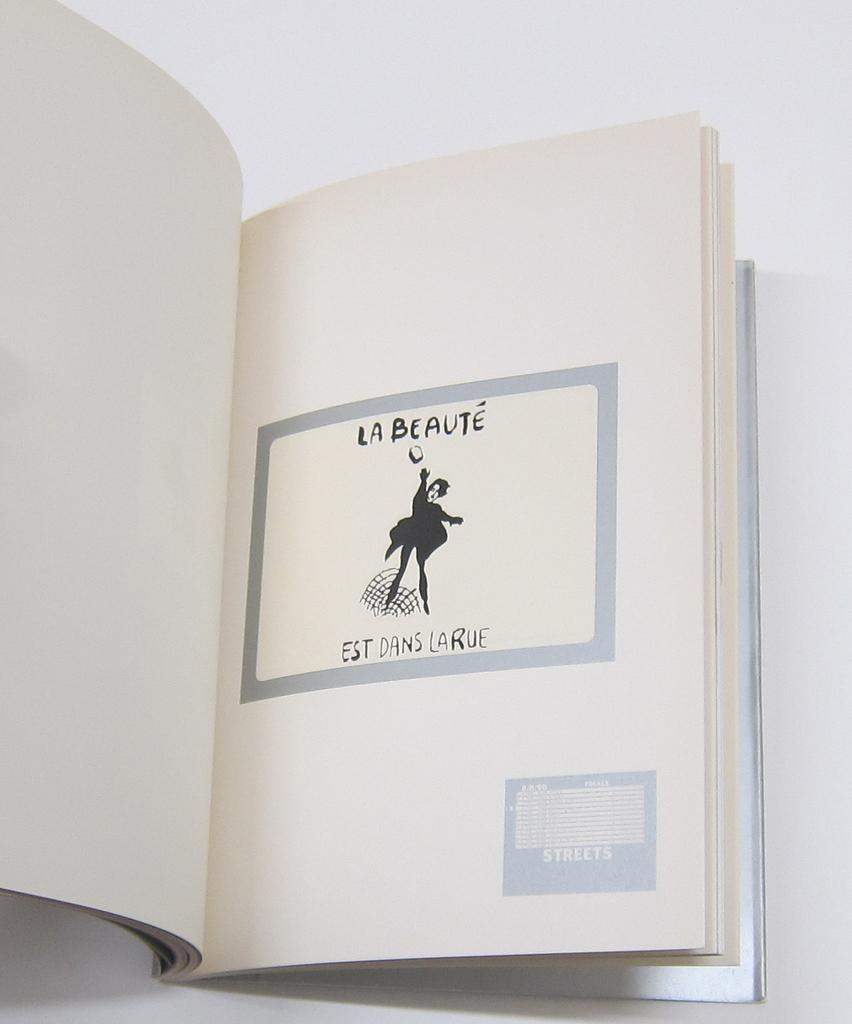<image>
Present a compact description of the photo's key features. A book is opened to a page that la Beaute Est Dans Larue with a woman in black throwing a stone 